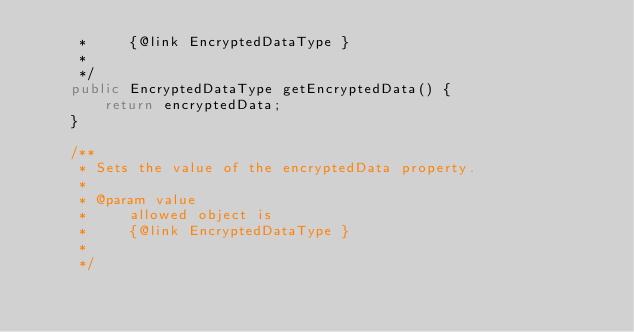<code> <loc_0><loc_0><loc_500><loc_500><_Java_>     *     {@link EncryptedDataType }
     *     
     */
    public EncryptedDataType getEncryptedData() {
        return encryptedData;
    }

    /**
     * Sets the value of the encryptedData property.
     * 
     * @param value
     *     allowed object is
     *     {@link EncryptedDataType }
     *     
     */</code> 